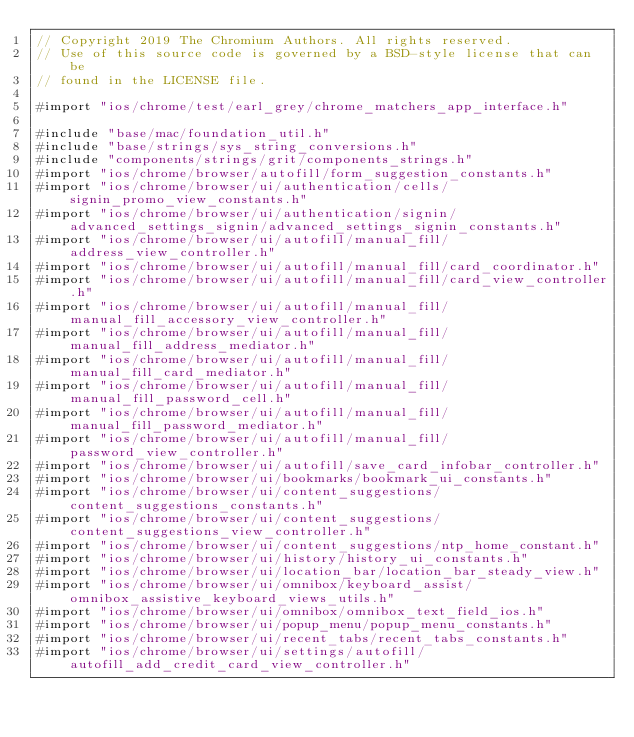<code> <loc_0><loc_0><loc_500><loc_500><_ObjectiveC_>// Copyright 2019 The Chromium Authors. All rights reserved.
// Use of this source code is governed by a BSD-style license that can be
// found in the LICENSE file.

#import "ios/chrome/test/earl_grey/chrome_matchers_app_interface.h"

#include "base/mac/foundation_util.h"
#include "base/strings/sys_string_conversions.h"
#include "components/strings/grit/components_strings.h"
#import "ios/chrome/browser/autofill/form_suggestion_constants.h"
#import "ios/chrome/browser/ui/authentication/cells/signin_promo_view_constants.h"
#import "ios/chrome/browser/ui/authentication/signin/advanced_settings_signin/advanced_settings_signin_constants.h"
#import "ios/chrome/browser/ui/autofill/manual_fill/address_view_controller.h"
#import "ios/chrome/browser/ui/autofill/manual_fill/card_coordinator.h"
#import "ios/chrome/browser/ui/autofill/manual_fill/card_view_controller.h"
#import "ios/chrome/browser/ui/autofill/manual_fill/manual_fill_accessory_view_controller.h"
#import "ios/chrome/browser/ui/autofill/manual_fill/manual_fill_address_mediator.h"
#import "ios/chrome/browser/ui/autofill/manual_fill/manual_fill_card_mediator.h"
#import "ios/chrome/browser/ui/autofill/manual_fill/manual_fill_password_cell.h"
#import "ios/chrome/browser/ui/autofill/manual_fill/manual_fill_password_mediator.h"
#import "ios/chrome/browser/ui/autofill/manual_fill/password_view_controller.h"
#import "ios/chrome/browser/ui/autofill/save_card_infobar_controller.h"
#import "ios/chrome/browser/ui/bookmarks/bookmark_ui_constants.h"
#import "ios/chrome/browser/ui/content_suggestions/content_suggestions_constants.h"
#import "ios/chrome/browser/ui/content_suggestions/content_suggestions_view_controller.h"
#import "ios/chrome/browser/ui/content_suggestions/ntp_home_constant.h"
#import "ios/chrome/browser/ui/history/history_ui_constants.h"
#import "ios/chrome/browser/ui/location_bar/location_bar_steady_view.h"
#import "ios/chrome/browser/ui/omnibox/keyboard_assist/omnibox_assistive_keyboard_views_utils.h"
#import "ios/chrome/browser/ui/omnibox/omnibox_text_field_ios.h"
#import "ios/chrome/browser/ui/popup_menu/popup_menu_constants.h"
#import "ios/chrome/browser/ui/recent_tabs/recent_tabs_constants.h"
#import "ios/chrome/browser/ui/settings/autofill/autofill_add_credit_card_view_controller.h"</code> 